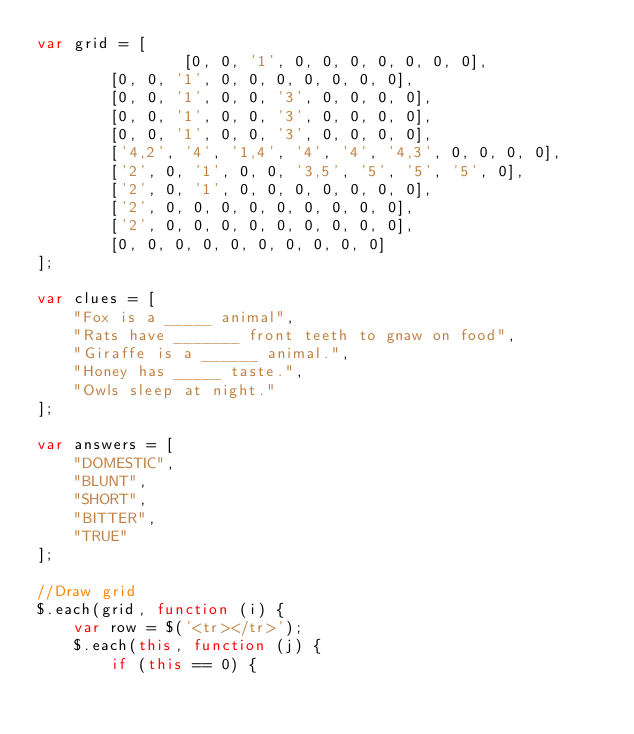Convert code to text. <code><loc_0><loc_0><loc_500><loc_500><_JavaScript_>var grid = [
                [0,	0, '1', 0, 0, 0, 0, 0, 0, 0],
				[0, 0, '1', 0, 0, 0, 0, 0, 0, 0],
				[0, 0, '1', 0, 0, '3', 0, 0, 0, 0],
				[0, 0, '1', 0, 0, '3', 0, 0, 0, 0],
				[0, 0, '1', 0, 0, '3', 0, 0, 0, 0],
				['4,2', '4', '1,4', '4', '4', '4,3', 0, 0, 0, 0],
				['2', 0, '1', 0, 0, '3,5', '5', '5', '5', 0],
				['2', 0, '1', 0, 0, 0, 0, 0, 0, 0],
				['2', 0, 0, 0, 0, 0, 0, 0, 0, 0],
				['2', 0, 0, 0, 0, 0, 0, 0, 0, 0],
				[0, 0, 0, 0, 0, 0, 0, 0, 0, 0]
];

var clues = [
    "Fox is a _____ animal",
    "Rats have _______ front teeth to gnaw on food",
    "Giraffe is a ______ animal.",
    "Honey has _____ taste.",
    "Owls sleep at night."
];

var answers = [
    "DOMESTIC",
    "BLUNT",
    "SHORT",
    "BITTER",
    "TRUE"
];

//Draw grid
$.each(grid, function (i) {
    var row = $('<tr></tr>');
    $.each(this, function (j) {
        if (this == 0) {</code> 